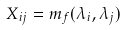<formula> <loc_0><loc_0><loc_500><loc_500>X _ { i j } = m _ { f } ( \lambda _ { i } , \lambda _ { j } )</formula> 